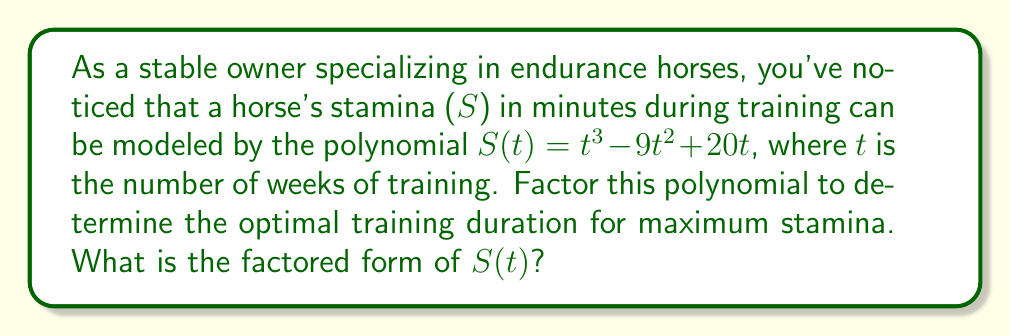Solve this math problem. Let's approach this step-by-step:

1) First, we need to factor out the greatest common factor (GCF):
   $S(t) = t^3 - 9t^2 + 20t$
   $S(t) = t(t^2 - 9t + 20)$

2) Now we need to factor the quadratic expression inside the parentheses: $t^2 - 9t + 20$

3) We're looking for two numbers that multiply to give 20 and add up to -9. These numbers are -4 and -5.

4) We can rewrite the quadratic as:
   $t^2 - 9t + 20 = t^2 - 4t - 5t + 20 = t(t - 4) - 5(t - 4) = (t - 4)(t - 5)$

5) Putting it all together:
   $S(t) = t(t^2 - 9t + 20)$
   $S(t) = t(t - 4)(t - 5)$

This factored form shows that stamina will be zero at 0, 4, and 5 weeks of training. The optimal training duration for maximum stamina would be between these values, likely around 2-3 weeks, but to determine the exact maximum, we'd need to use calculus to find the local maximum of this function.
Answer: $S(t) = t(t - 4)(t - 5)$ 